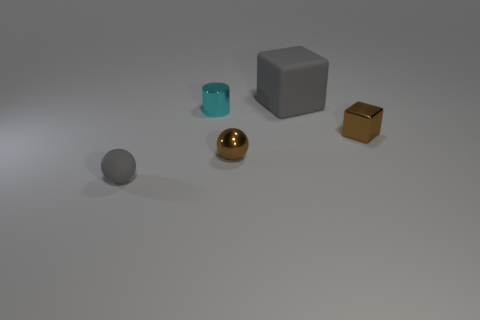Add 3 small gray rubber things. How many objects exist? 8 Subtract all gray balls. How many balls are left? 1 Subtract 1 cubes. How many cubes are left? 1 Subtract all cylinders. How many objects are left? 4 Subtract all yellow balls. Subtract all red cylinders. How many balls are left? 2 Subtract all blue spheres. How many gray blocks are left? 1 Subtract all matte objects. Subtract all large cyan shiny cubes. How many objects are left? 3 Add 3 gray balls. How many gray balls are left? 4 Add 4 large cyan cubes. How many large cyan cubes exist? 4 Subtract 0 green cylinders. How many objects are left? 5 